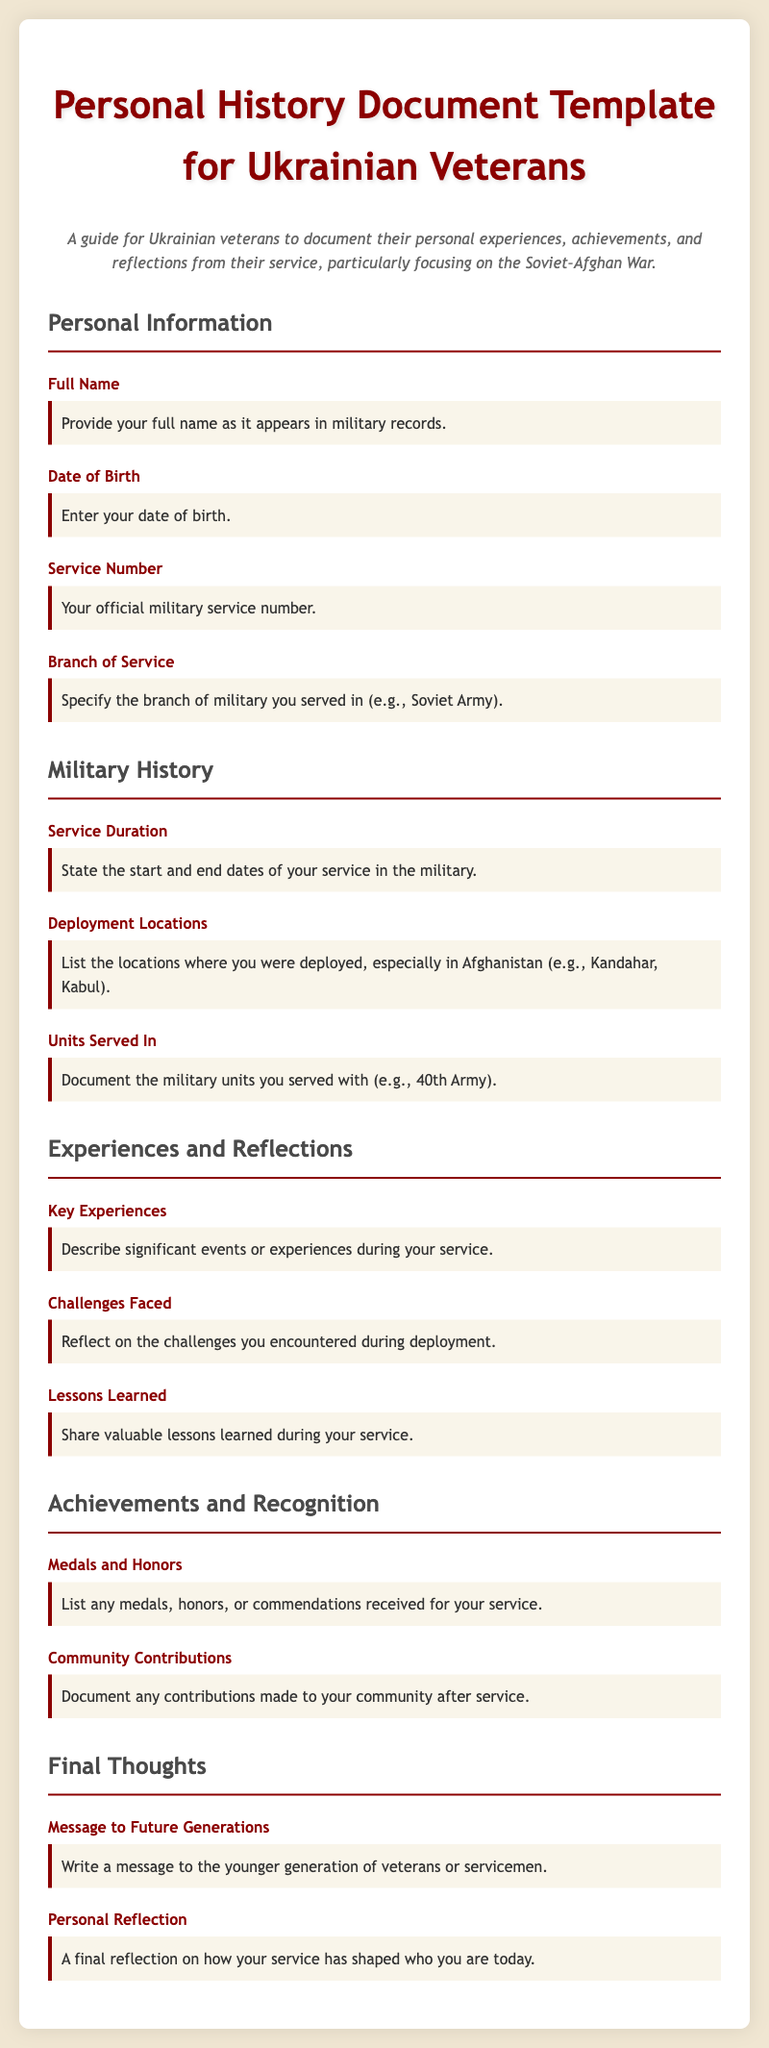What is the title of the document? The title is found at the top of the document, introducing its purpose for veterans.
Answer: Personal History Document Template for Ukrainian Veterans What is included in the personal information section? This section specifies the type of personal details that veterans need to provide.
Answer: Full Name, Date of Birth, Service Number, Branch of Service What is the purpose of the "Key Experiences" field? It prompts veterans to elaborate on significant events during their service.
Answer: Describe significant events or experiences during your service What does the "Challenges Faced" section ask for? It requests veterans to reflect on their difficulties during deployment.
Answer: Reflect on the challenges you encountered during deployment Which military units are veterans asked to document? The document specifies that veterans should list the units wherein they served.
Answer: Document the military units you served with What message do veterans need to write for future generations? This field invites veterans to address their thoughts for the younger generation.
Answer: Write a message to the younger generation of veterans or servicemen What kind of contributions are mentioned in the achievements section? It asks veterans to highlight their efforts within their communities post-service.
Answer: Document any contributions made to your community after service What should veterans include about medals in the achievements section? This section specifically requests a list of any awards veterans have received.
Answer: List any medals, honors, or commendations received for your service 